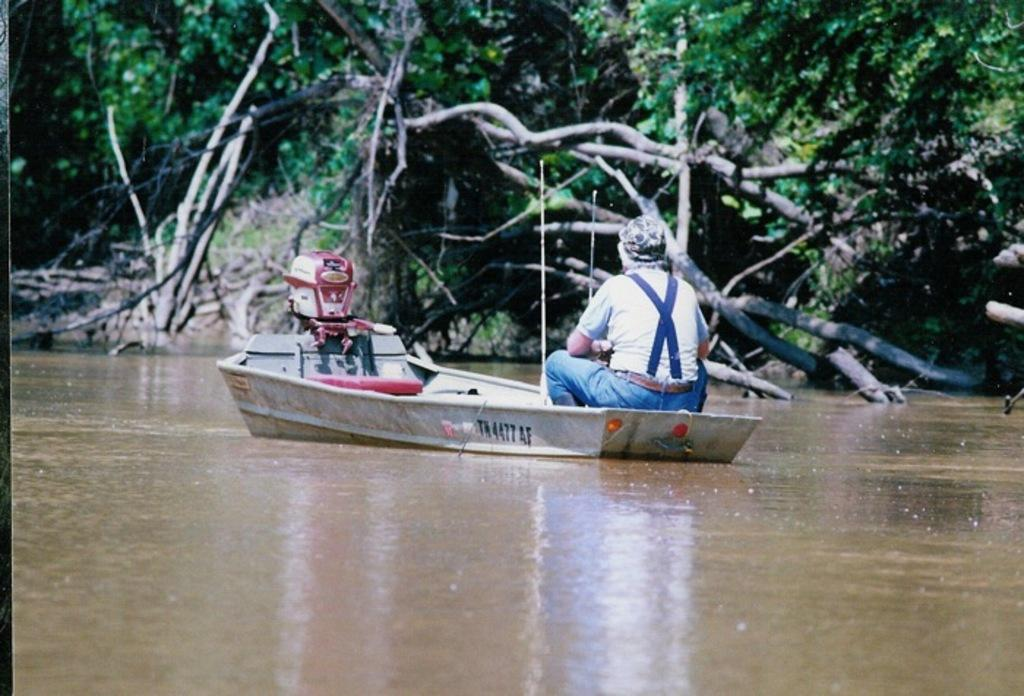What is the person in the image doing? There is a person sitting on a boat in the image. What else can be seen in the image besides the person? There is an object in the image. What type of natural environment is visible in the background? There are trees in the background of the image. What is visible at the bottom of the image? There is water visible at the bottom of the image. What type of mitten is the person wearing in the image? There is no mitten present in the image; the person is sitting on a boat. What direction is the cemetery facing in the image? There is no cemetery present in the image; it features a person sitting on a boat, trees in the background, and water at the bottom. 